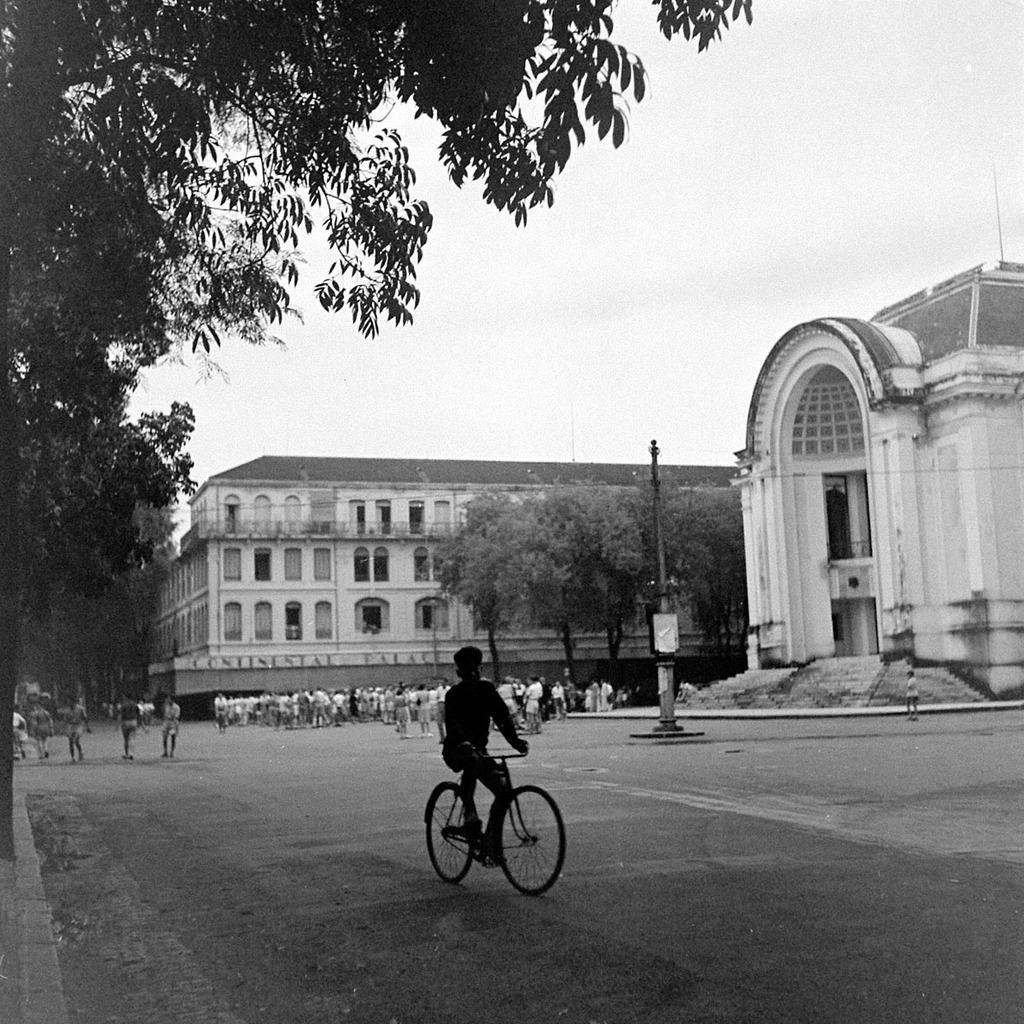In one or two sentences, can you explain what this image depicts? In this picture there is a person riding bicycle on the road. At the back there are group of people and there is a building and there are trees and there is a pole on the footpath. At the top there is sky. At the bottom there is a road. 